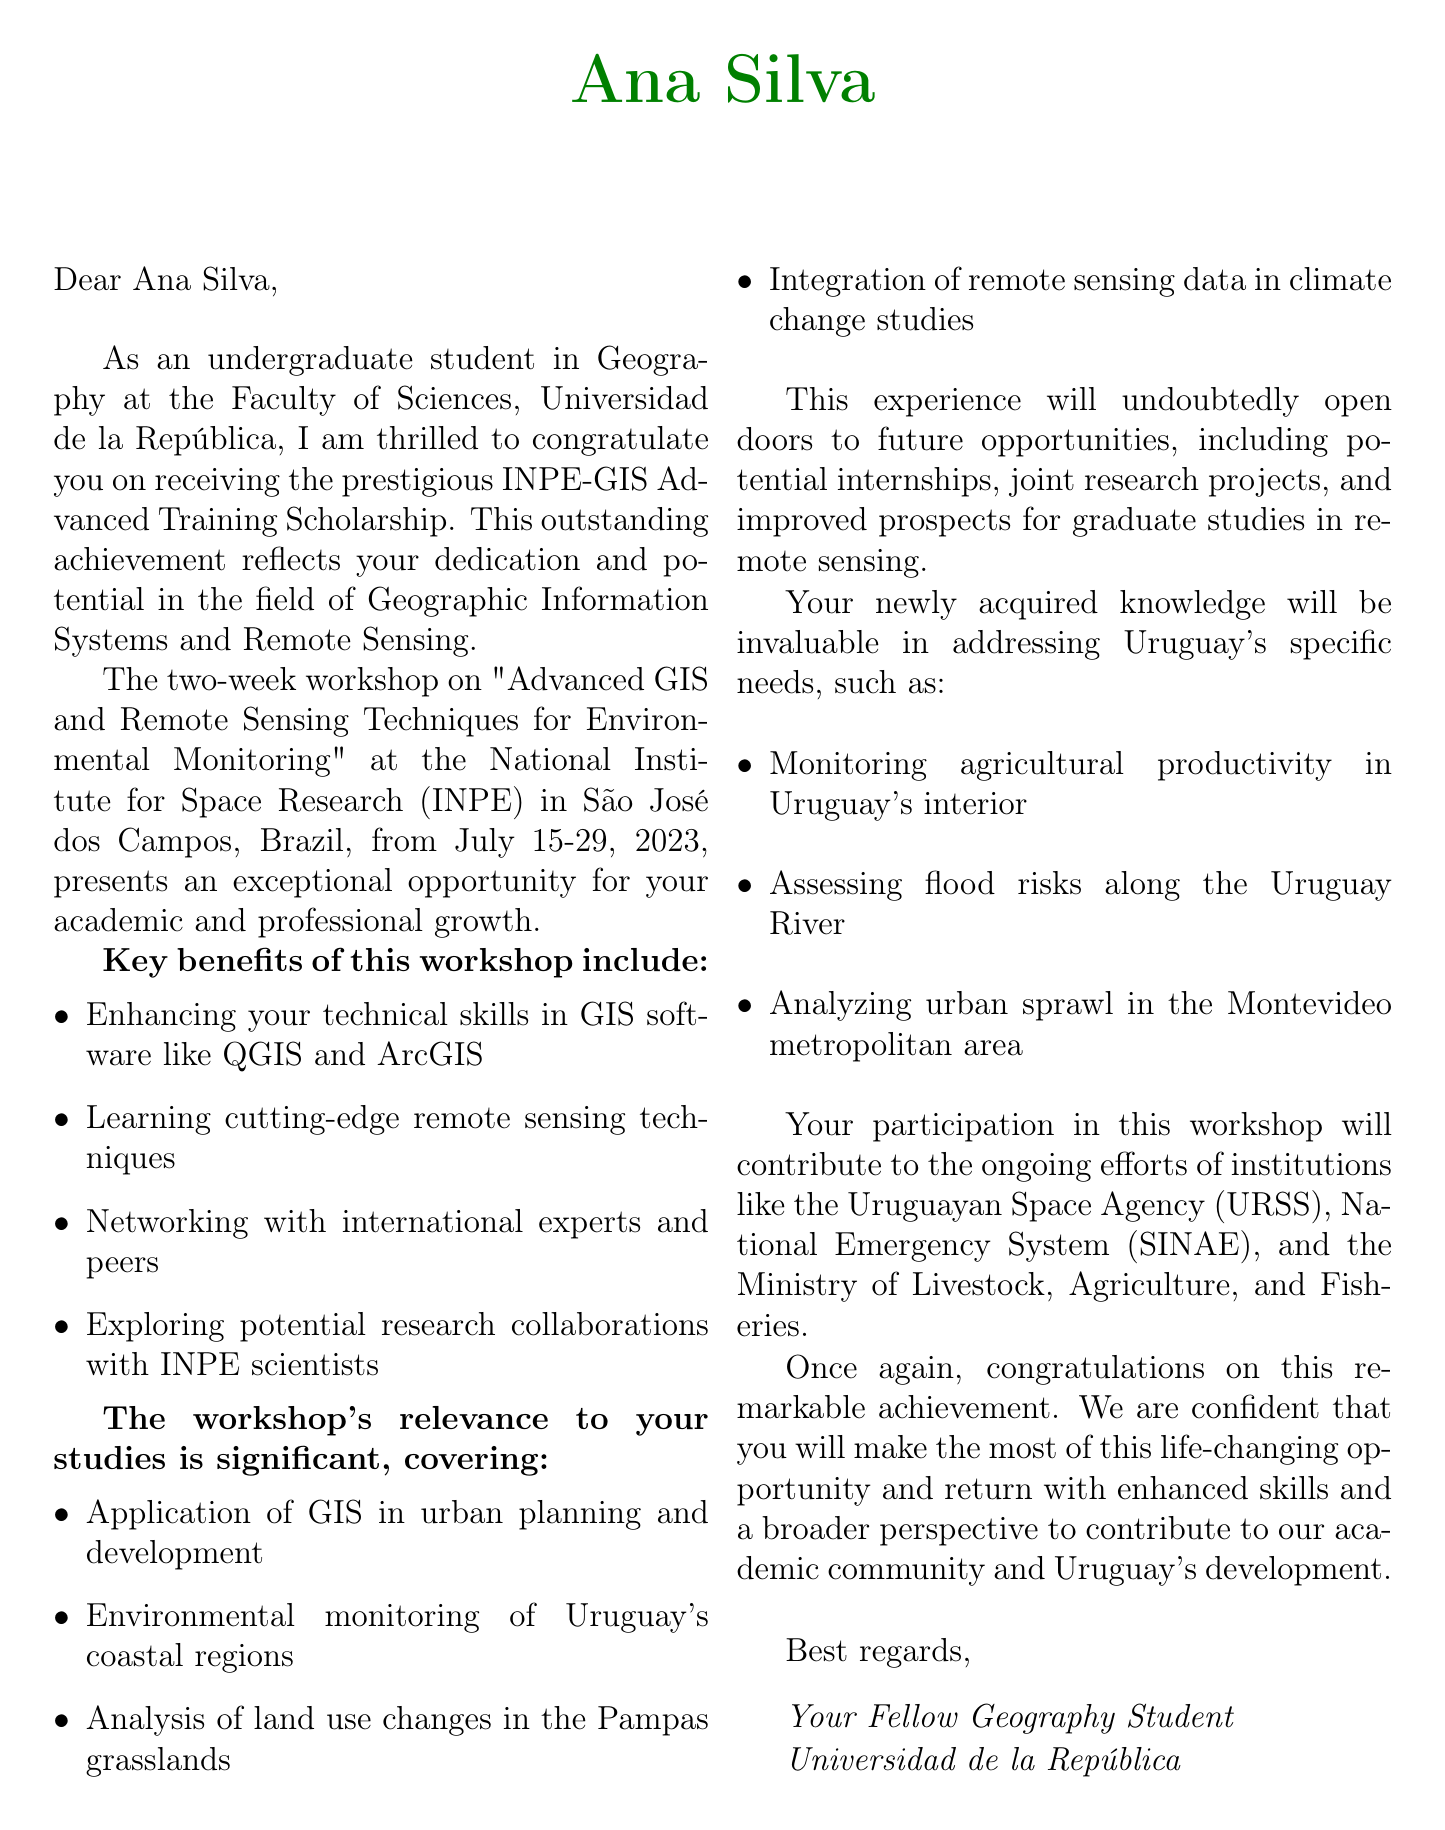What is the name of the scholarship? The scholarship name is explicitly mentioned in the document as INPE-GIS Advanced Training Scholarship.
Answer: INPE-GIS Advanced Training Scholarship Who is the provider of the scholarship? The document states that the provider of the scholarship is the National Institute for Space Research (INPE).
Answer: National Institute for Space Research (INPE) What are the workshop dates? The document lists the workshop dates as July 15-29, 2023.
Answer: July 15-29, 2023 How long is the workshop? The duration of the workshop is clearly stated in the letter as 2 weeks.
Answer: 2 weeks What key topic involves machine learning? One of the key topics mentioned is specifically stated as machine learning applications in remote sensing.
Answer: Machine learning applications in remote sensing What relevance does GIS have to urban planning? The document highlights the application of GIS in urban planning and development as a significant aspect.
Answer: Application of GIS in urban planning and development What are potential future opportunities mentioned? The letter states several future opportunities including potential internship at INPE's Earth Observation Division.
Answer: Potential internship at INPE's Earth Observation Division How does the letter express gratitude? The letter expresses gratitude by stating that the recipient is deeply honored and grateful.
Answer: Deeply honored and grateful What is the main focus of the workshop? The main focus of the workshop, as stated, is on advanced GIS and remote sensing techniques for environmental monitoring.
Answer: Advanced GIS and Remote Sensing Techniques for Environmental Monitoring 